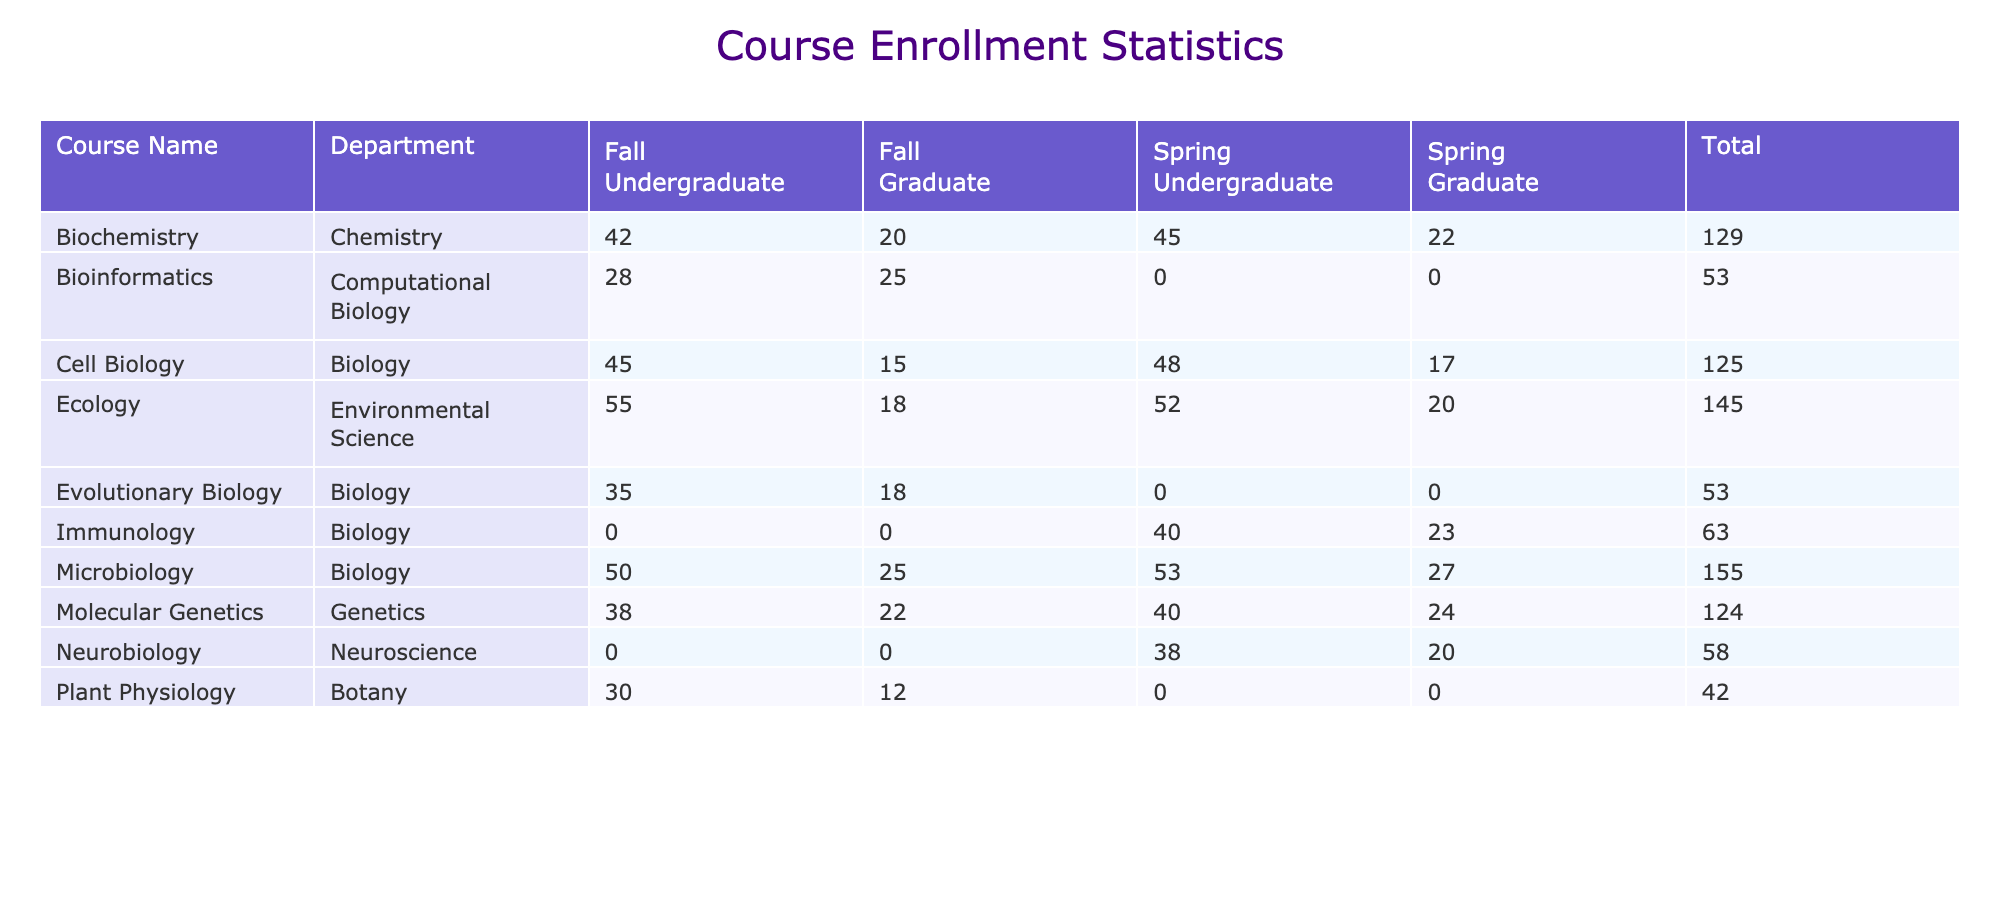What is the total enrollment for the course "Microbiology" in Spring 2024? The data for "Microbiology" in Spring 2024 shows an enrollment count of 53 for Undergraduate and 27 for Graduate. Summing these values gives 53 + 27 = 80.
Answer: 80 Which course had the highest total enrollment in Fall 2023? To find the highest total enrollment in Fall 2023, we review the total enrollment counts for each course in that semester. The courses and their respective total enrollments are: Cell Biology (60), Molecular Genetics (60), Ecology (73), Biochemistry (62), Microbiology (75), Evolutionary Biology (53), and Plant Physiology (42). The highest value is 75 from Microbiology.
Answer: Microbiology Is the enrollment for "Molecular Genetics" higher in Spring 2024 than in Fall 2023? In Fall 2023, "Molecular Genetics" had an enrollment of 38 for Undergraduate and 22 for Graduate, totaling 60. In Spring 2024, the enrollment figures are 40 for Undergraduate and 24 for Graduate, totaling 64. Since 64 is greater than 60, the enrollment in Spring 2024 is higher.
Answer: Yes What is the average enrollment for graduate-level courses across all semesters? To find the average enrollment for graduate-level courses, we sum all the graduate enrollments and then divide by the number of courses. The total graduate enrollments are: 15 + 22 + 18 + 20 + 25 + 17 + 24 + 20 + 20 + 23 + 27 + 12 =  291. There are 12 graduate course enrollments total, therefore the average is 291 / 12 = 24.25.
Answer: 24.25 In Fall 2023, how many more students were enrolled in Ecology compared to Plant Physiology? In Fall 2023, Ecology had 55 undergraduates and 18 graduates, summing to 73. Plant Physiology had 30 undergraduates and 12 graduates, summing to 42. The difference in enrollment is 73 - 42 = 31.
Answer: 31 Which department had the largest number of students enrolled in Spring 2024? To identify the department with the largest enrollment in Spring 2024, we sum the enrollments by department: Biology (40 + 23 + 53 + 27 = 143), Genetics (40 + 24 = 64), Environmental Science (52 + 20 = 72), Chemistry (45 + 22 = 67), and Neuroscience (38 + 20 = 58). The largest total is 143 for Biology.
Answer: Biology Is the total enrollment for undergraduate students in Fall 2023 greater than in Spring 2024? In Fall 2023, the undergraduate enrollment totals are: 45 (Cell Biology) + 38 (Molecular Genetics) + 55 (Ecology) + 42 (Biochemistry) + 50 (Microbiology) + 35 (Evolutionary Biology) + 30 (Plant Physiology) + 28 (Bioinformatics) = 323. In Spring 2024, the totals are: 48 (Cell Biology) + 40 (Molecular Genetics) + 52 (Ecology) + 45 (Biochemistry) + 53 (Microbiology) + 40 (Immunology) + 38 (Neurobiology) = 366. Since 366 is greater than 323, the answer is no.
Answer: No What is the total enrollment count for all undergraduate courses in both semesters combined? To calculate total undergraduate enrollment for all courses, we sum the undergraduate counts: Fall 2023: 45 + 38 + 55 + 42 + 50 + 35 + 30 + 28 = 323, and Spring 2024: 48 + 40 + 52 + 45 + 53 + 40 + 38 = 366. Adding these totals gives 323 + 366 = 689.
Answer: 689 